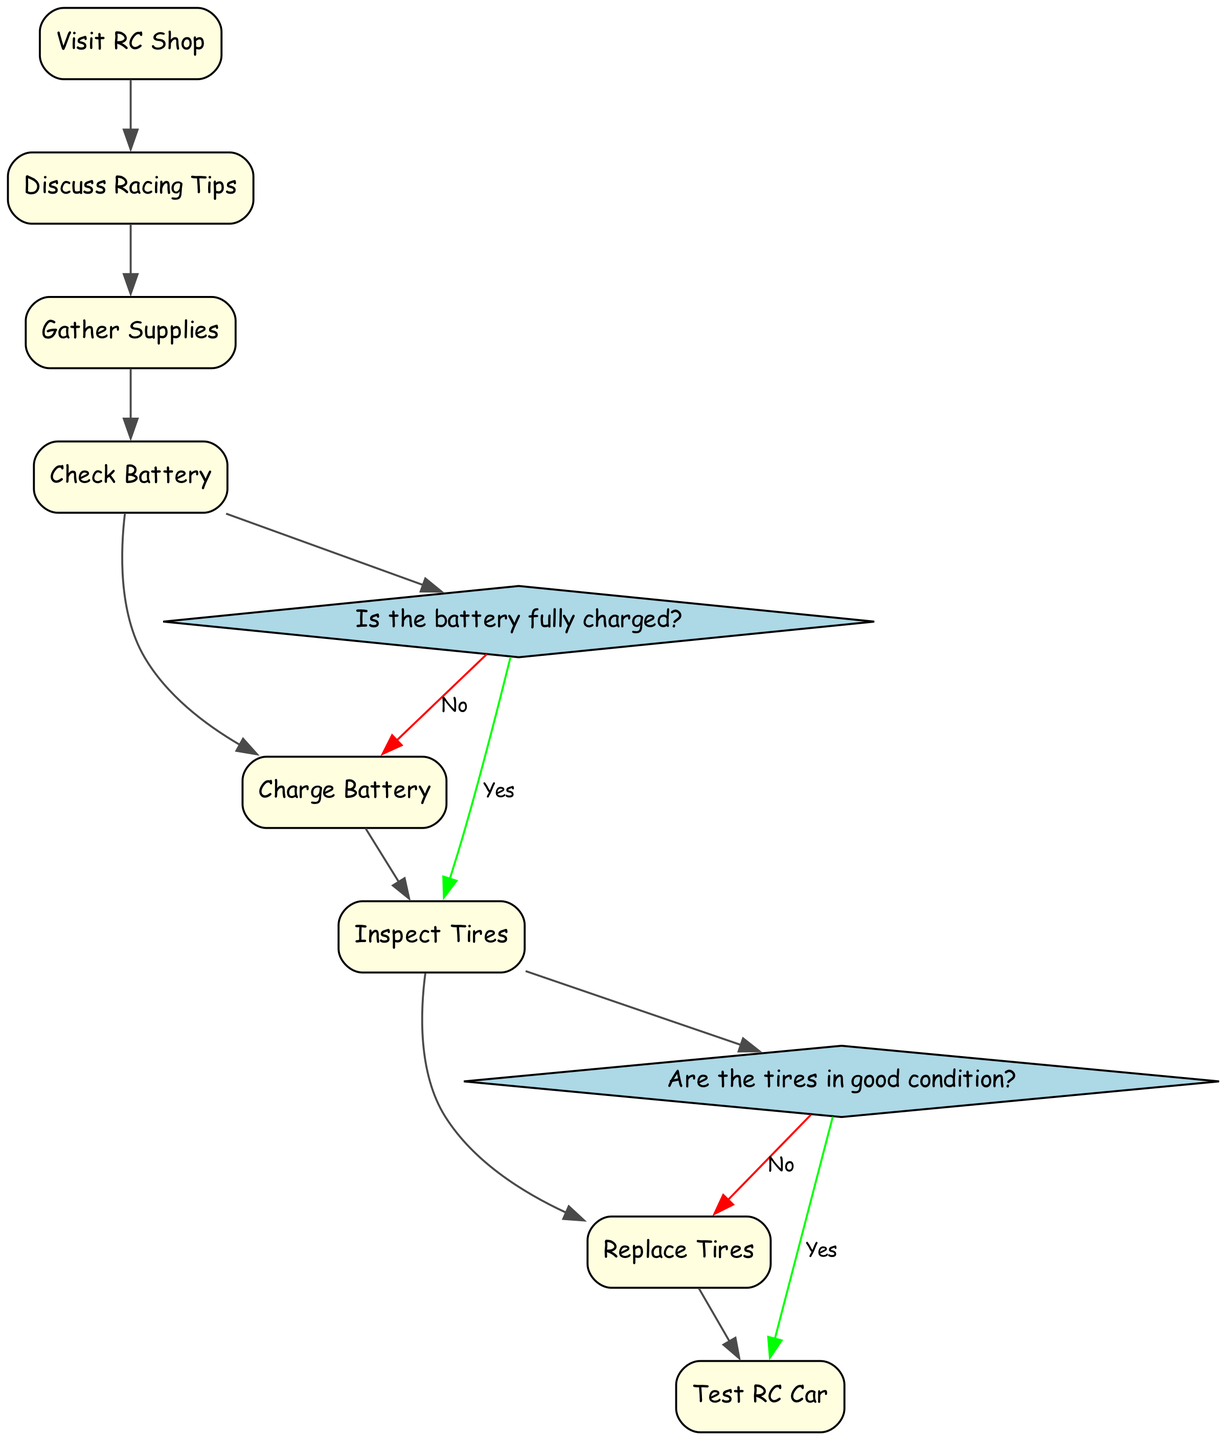What is the first step in preparing for racing day? The first step outlined in the diagram is "Visit RC Shop." This is the starting point that initiates the entire process of preparing for the race.
Answer: Visit RC Shop How many decision points are in the diagram? There are two decision points present in the diagram, which are related to the battery charge and the condition of the tires.
Answer: 2 What comes after "Check Battery"? The next step after "Check Battery" is to evaluate if the battery is fully charged, which leads to the decision point "Battery Fully Charged?"
Answer: Battery Fully Charged? If the tires are in bad condition, what is the next step? If the tires are in bad condition, you would proceed to the step "Replace Tires," as indicated in the decision point "Tires in Good Condition?".
Answer: Replace Tires What is the final step before testing the RC car? The last preparatory step before "Test RC Car" is "Replace Tires," which is done if the tires are determined to be in bad condition.
Answer: Replace Tires What activity follows "Charge Battery"? After "Charge Battery," the next activity is "Inspect Tires," where the condition of the tires is checked before racing.
Answer: Inspect Tires Which activity leads directly to "Test RC Car"? The activity that leads directly to "Test RC Car" is "Inspect Tires," provided the tires are confirmed to be in good condition according to the decision point.
Answer: Inspect Tires 